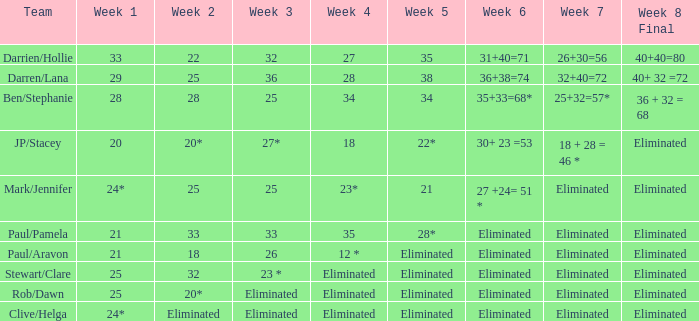What is the team for week one out of 28? Ben/Stephanie. 